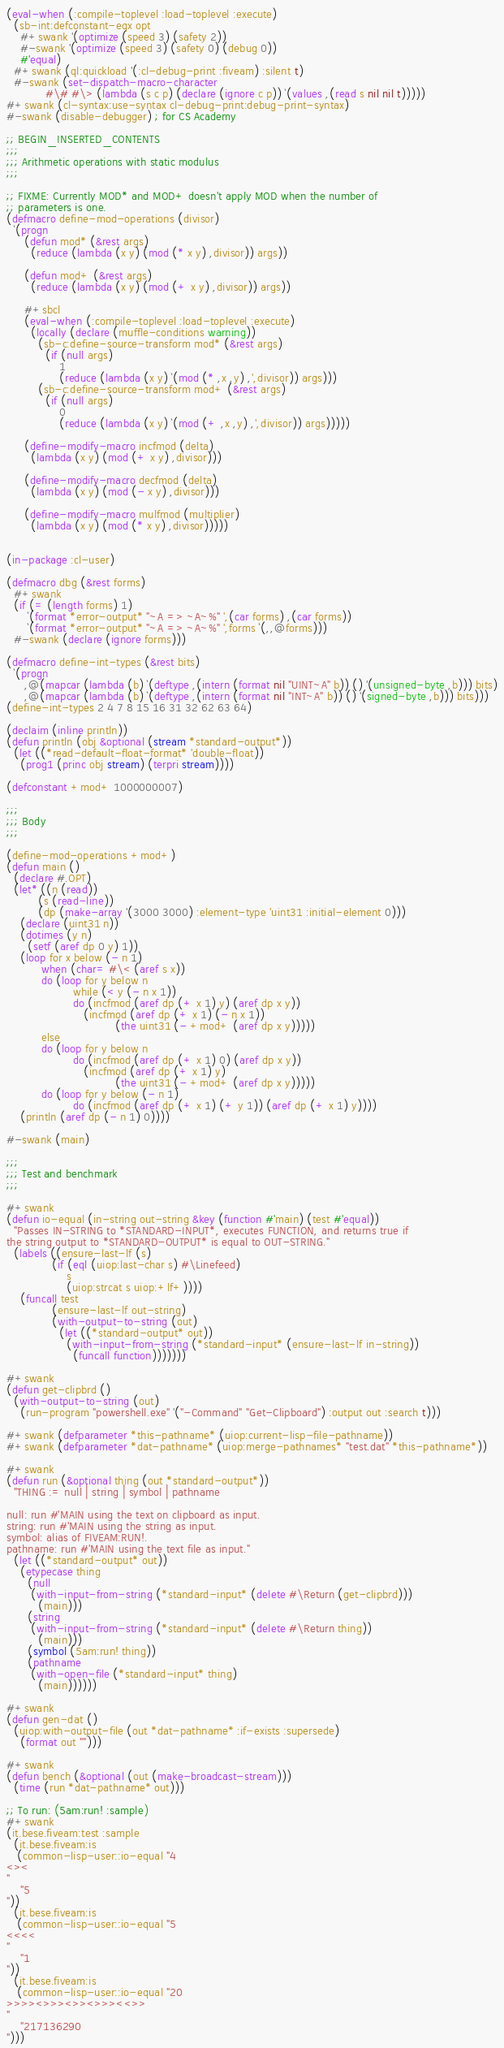Convert code to text. <code><loc_0><loc_0><loc_500><loc_500><_Lisp_>(eval-when (:compile-toplevel :load-toplevel :execute)
  (sb-int:defconstant-eqx opt
    #+swank '(optimize (speed 3) (safety 2))
    #-swank '(optimize (speed 3) (safety 0) (debug 0))
    #'equal)
  #+swank (ql:quickload '(:cl-debug-print :fiveam) :silent t)
  #-swank (set-dispatch-macro-character
           #\# #\> (lambda (s c p) (declare (ignore c p)) `(values ,(read s nil nil t)))))
#+swank (cl-syntax:use-syntax cl-debug-print:debug-print-syntax)
#-swank (disable-debugger) ; for CS Academy

;; BEGIN_INSERTED_CONTENTS
;;;
;;; Arithmetic operations with static modulus
;;;

;; FIXME: Currently MOD* and MOD+ doesn't apply MOD when the number of
;; parameters is one.
(defmacro define-mod-operations (divisor)
  `(progn
     (defun mod* (&rest args)
       (reduce (lambda (x y) (mod (* x y) ,divisor)) args))

     (defun mod+ (&rest args)
       (reduce (lambda (x y) (mod (+ x y) ,divisor)) args))

     #+sbcl
     (eval-when (:compile-toplevel :load-toplevel :execute)
       (locally (declare (muffle-conditions warning))
         (sb-c:define-source-transform mod* (&rest args)
           (if (null args)
               1
               (reduce (lambda (x y) `(mod (* ,x ,y) ,',divisor)) args)))
         (sb-c:define-source-transform mod+ (&rest args)
           (if (null args)
               0
               (reduce (lambda (x y) `(mod (+ ,x ,y) ,',divisor)) args)))))

     (define-modify-macro incfmod (delta)
       (lambda (x y) (mod (+ x y) ,divisor)))

     (define-modify-macro decfmod (delta)
       (lambda (x y) (mod (- x y) ,divisor)))

     (define-modify-macro mulfmod (multiplier)
       (lambda (x y) (mod (* x y) ,divisor)))))


(in-package :cl-user)

(defmacro dbg (&rest forms)
  #+swank
  (if (= (length forms) 1)
      `(format *error-output* "~A => ~A~%" ',(car forms) ,(car forms))
      `(format *error-output* "~A => ~A~%" ',forms `(,,@forms)))
  #-swank (declare (ignore forms)))

(defmacro define-int-types (&rest bits)
  `(progn
     ,@(mapcar (lambda (b) `(deftype ,(intern (format nil "UINT~A" b)) () '(unsigned-byte ,b))) bits)
     ,@(mapcar (lambda (b) `(deftype ,(intern (format nil "INT~A" b)) () '(signed-byte ,b))) bits)))
(define-int-types 2 4 7 8 15 16 31 32 62 63 64)

(declaim (inline println))
(defun println (obj &optional (stream *standard-output*))
  (let ((*read-default-float-format* 'double-float))
    (prog1 (princ obj stream) (terpri stream))))

(defconstant +mod+ 1000000007)

;;;
;;; Body
;;;

(define-mod-operations +mod+)
(defun main ()
  (declare #.OPT)
  (let* ((n (read))
         (s (read-line))
         (dp (make-array '(3000 3000) :element-type 'uint31 :initial-element 0)))
    (declare (uint31 n))
    (dotimes (y n)
      (setf (aref dp 0 y) 1))
    (loop for x below (- n 1)
          when (char= #\< (aref s x))
          do (loop for y below n
                   while (< y (- n x 1))
                   do (incfmod (aref dp (+ x 1) y) (aref dp x y))
                      (incfmod (aref dp (+ x 1) (- n x 1))
                               (the uint31 (- +mod+ (aref dp x y)))))
          else
          do (loop for y below n
                   do (incfmod (aref dp (+ x 1) 0) (aref dp x y))
                      (incfmod (aref dp (+ x 1) y)
                               (the uint31 (- +mod+ (aref dp x y)))))
          do (loop for y below (- n 1)
                   do (incfmod (aref dp (+ x 1) (+ y 1)) (aref dp (+ x 1) y))))
    (println (aref dp (- n 1) 0))))

#-swank (main)

;;;
;;; Test and benchmark
;;;

#+swank
(defun io-equal (in-string out-string &key (function #'main) (test #'equal))
  "Passes IN-STRING to *STANDARD-INPUT*, executes FUNCTION, and returns true if
the string output to *STANDARD-OUTPUT* is equal to OUT-STRING."
  (labels ((ensure-last-lf (s)
             (if (eql (uiop:last-char s) #\Linefeed)
                 s
                 (uiop:strcat s uiop:+lf+))))
    (funcall test
             (ensure-last-lf out-string)
             (with-output-to-string (out)
               (let ((*standard-output* out))
                 (with-input-from-string (*standard-input* (ensure-last-lf in-string))
                   (funcall function)))))))

#+swank
(defun get-clipbrd ()
  (with-output-to-string (out)
    (run-program "powershell.exe" '("-Command" "Get-Clipboard") :output out :search t)))

#+swank (defparameter *this-pathname* (uiop:current-lisp-file-pathname))
#+swank (defparameter *dat-pathname* (uiop:merge-pathnames* "test.dat" *this-pathname*))

#+swank
(defun run (&optional thing (out *standard-output*))
  "THING := null | string | symbol | pathname

null: run #'MAIN using the text on clipboard as input.
string: run #'MAIN using the string as input.
symbol: alias of FIVEAM:RUN!.
pathname: run #'MAIN using the text file as input."
  (let ((*standard-output* out))
    (etypecase thing
      (null
       (with-input-from-string (*standard-input* (delete #\Return (get-clipbrd)))
         (main)))
      (string
       (with-input-from-string (*standard-input* (delete #\Return thing))
         (main)))
      (symbol (5am:run! thing))
      (pathname
       (with-open-file (*standard-input* thing)
         (main))))))

#+swank
(defun gen-dat ()
  (uiop:with-output-file (out *dat-pathname* :if-exists :supersede)
    (format out "")))

#+swank
(defun bench (&optional (out (make-broadcast-stream)))
  (time (run *dat-pathname* out)))

;; To run: (5am:run! :sample)
#+swank
(it.bese.fiveam:test :sample
  (it.bese.fiveam:is
   (common-lisp-user::io-equal "4
<><
"
    "5
"))
  (it.bese.fiveam:is
   (common-lisp-user::io-equal "5
<<<<
"
    "1
"))
  (it.bese.fiveam:is
   (common-lisp-user::io-equal "20
>>>><>>><>><>>><<>>
"
    "217136290
")))
</code> 